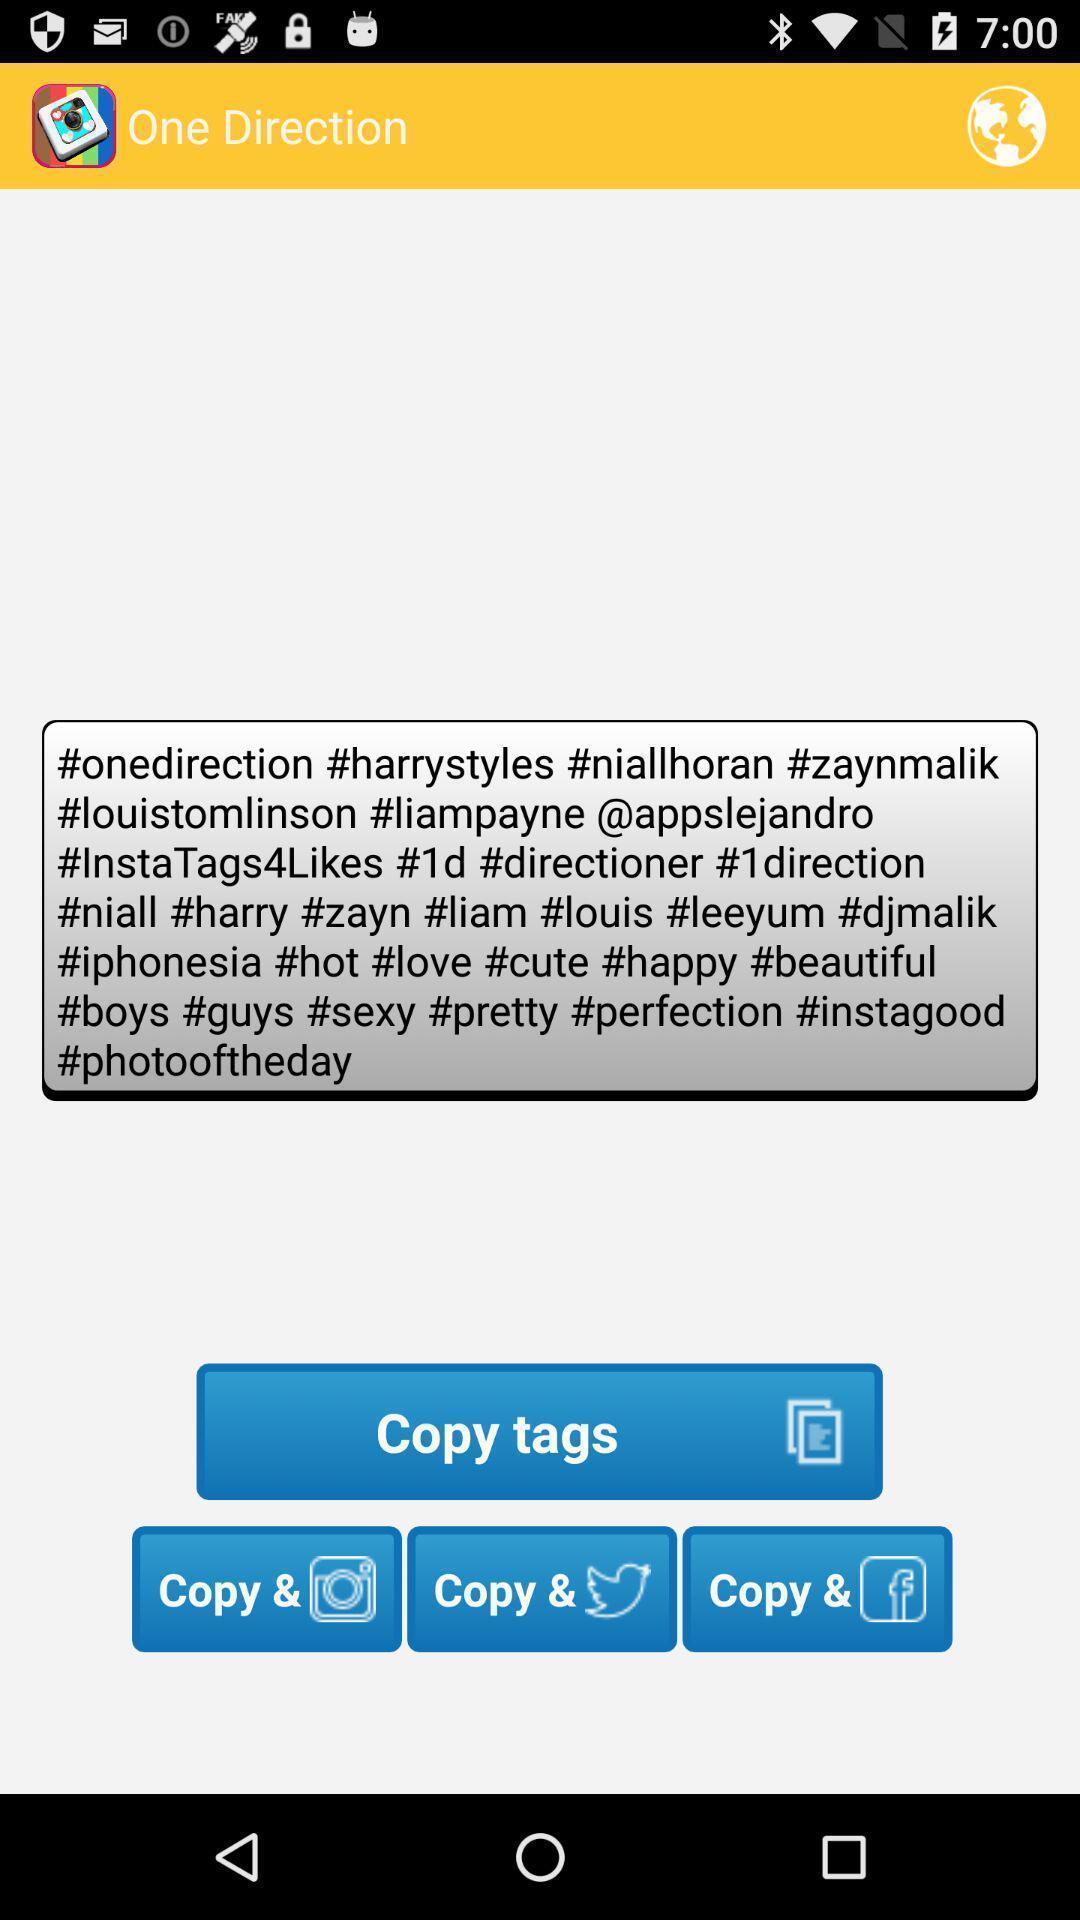Describe the visual elements of this screenshot. Text displayed with options to copy. 